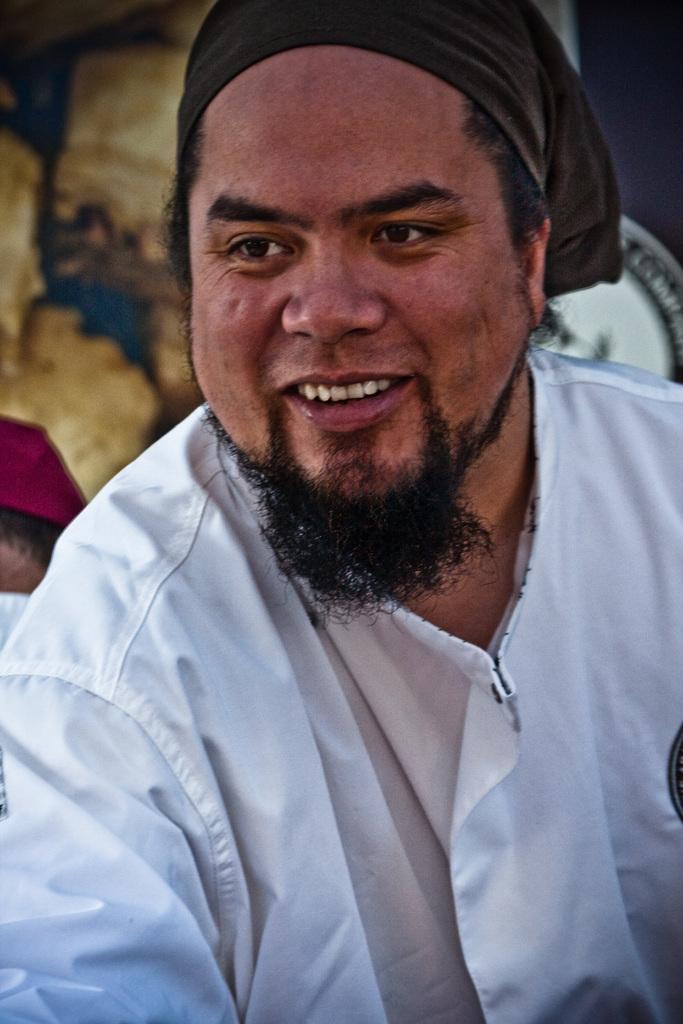Could you give a brief overview of what you see in this image? In this image we can see a person wearing white shirt with a smile. In the background there is a wall. 